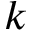Convert formula to latex. <formula><loc_0><loc_0><loc_500><loc_500>k</formula> 